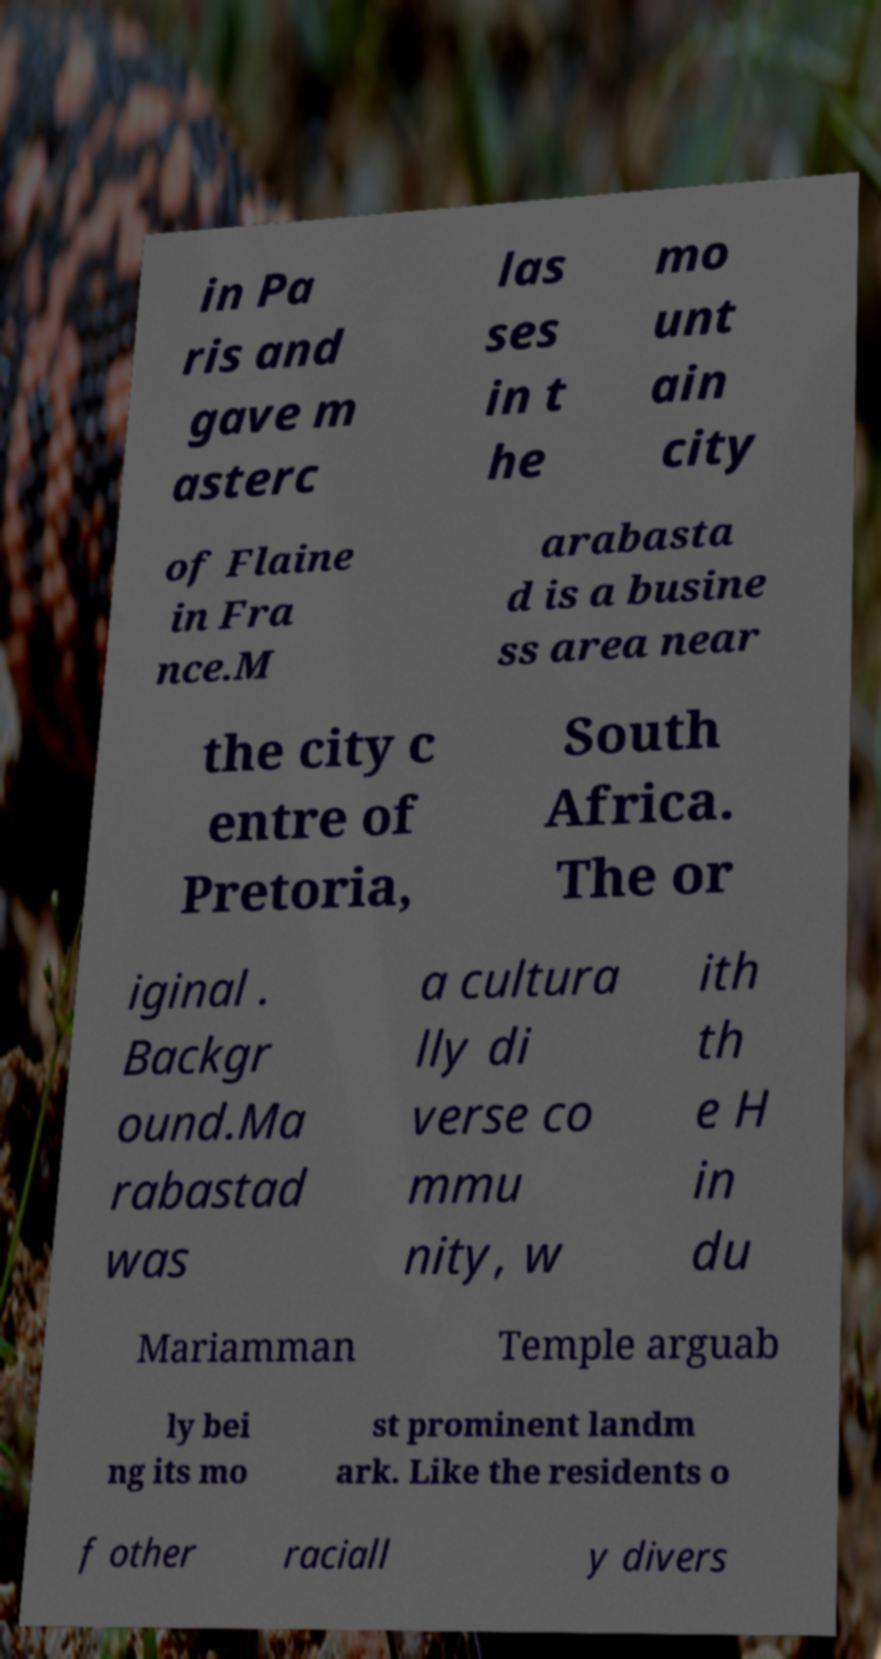There's text embedded in this image that I need extracted. Can you transcribe it verbatim? in Pa ris and gave m asterc las ses in t he mo unt ain city of Flaine in Fra nce.M arabasta d is a busine ss area near the city c entre of Pretoria, South Africa. The or iginal . Backgr ound.Ma rabastad was a cultura lly di verse co mmu nity, w ith th e H in du Mariamman Temple arguab ly bei ng its mo st prominent landm ark. Like the residents o f other raciall y divers 